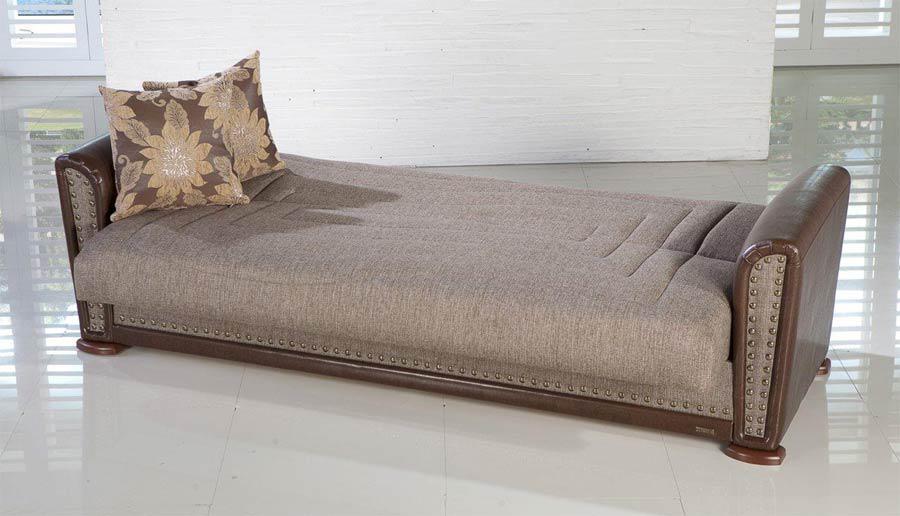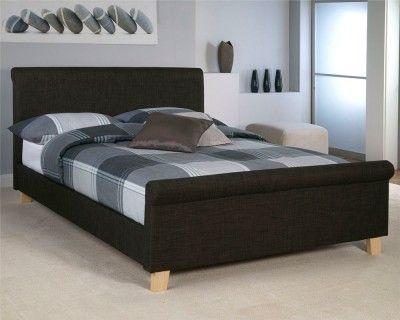The first image is the image on the left, the second image is the image on the right. For the images displayed, is the sentence "Each image shows a bed with non-white pillows on top and a dark head- and foot-board, displayed at an angle." factually correct? Answer yes or no. Yes. The first image is the image on the left, the second image is the image on the right. Examine the images to the left and right. Is the description "The left and right image contains the same number of bed." accurate? Answer yes or no. Yes. 